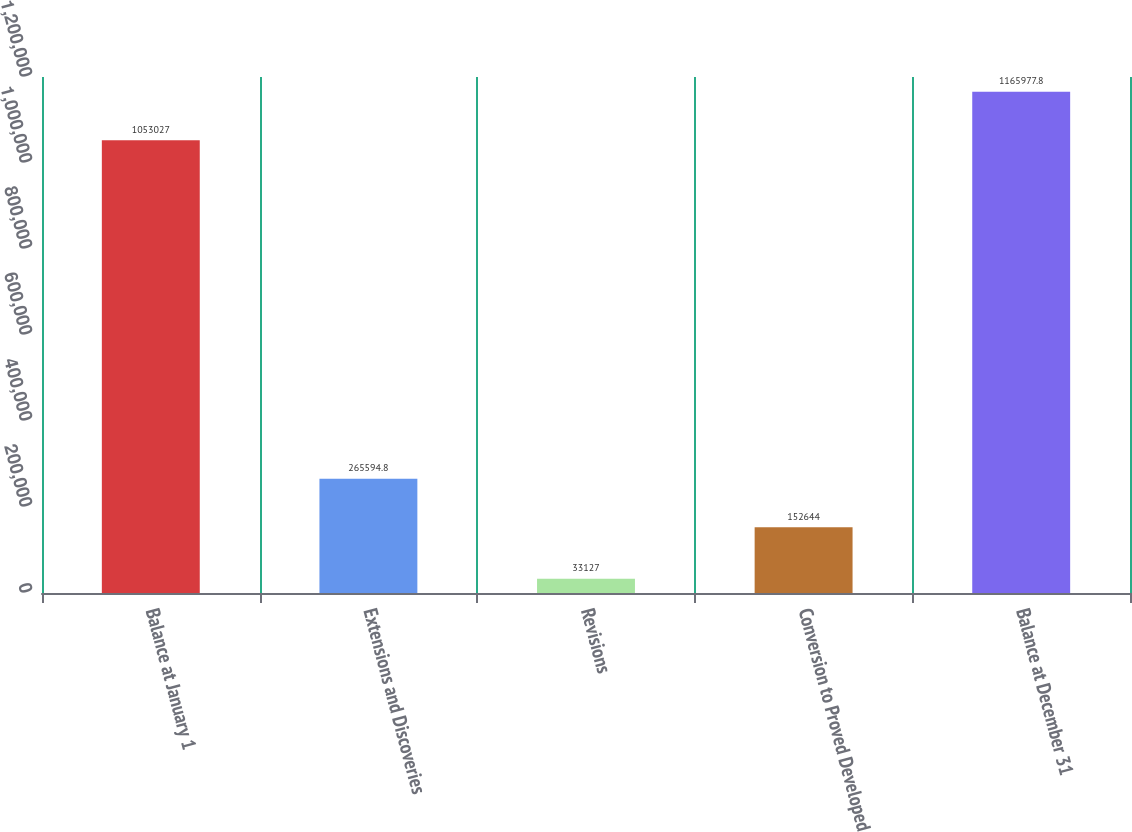Convert chart to OTSL. <chart><loc_0><loc_0><loc_500><loc_500><bar_chart><fcel>Balance at January 1<fcel>Extensions and Discoveries<fcel>Revisions<fcel>Conversion to Proved Developed<fcel>Balance at December 31<nl><fcel>1.05303e+06<fcel>265595<fcel>33127<fcel>152644<fcel>1.16598e+06<nl></chart> 